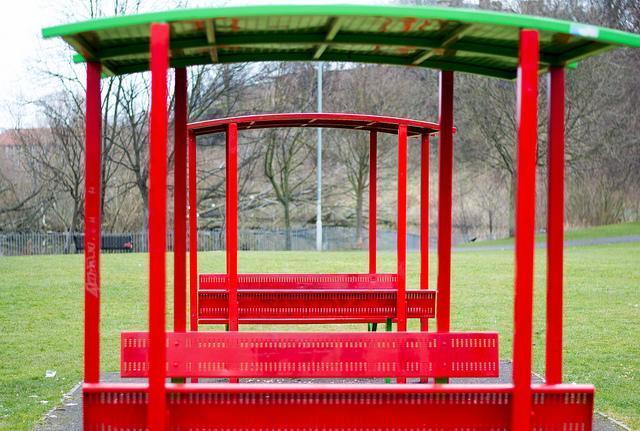How many benches can you see?
Give a very brief answer. 3. How many dogs are running in the surf?
Give a very brief answer. 0. 